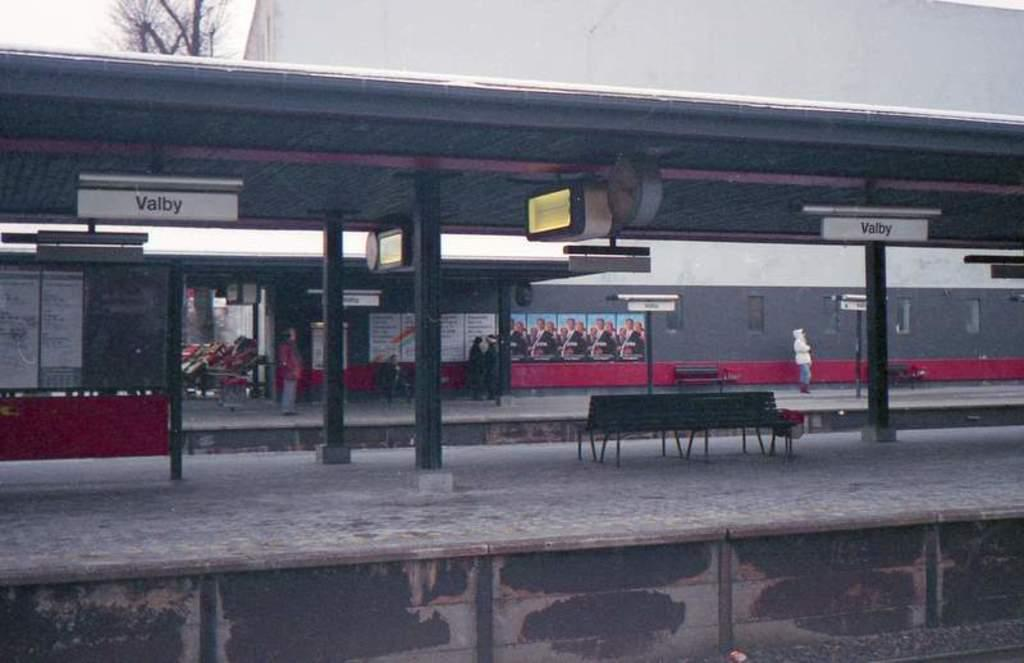What type of location is shown in the image? The image depicts a railway station. What can be found on the platform in the middle of the image? There are benches on the platform in the image. What is visible in the background of the image? There is a building and a tree in the background of the image. What committee is meeting in the railway station in the image? There is no committee meeting in the railway station in the image. Can you see a church in the background of the image? No, there is no church visible in the background of the image; it features a building and a tree. 